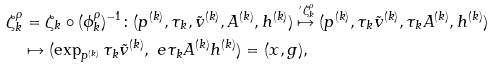<formula> <loc_0><loc_0><loc_500><loc_500>\zeta ^ { \rho } _ { k } & = \zeta _ { k } \circ ( \phi ^ { \rho } _ { k } ) ^ { - 1 } \colon ( p ^ { ( k ) } , \tau _ { k } , \tilde { v } ^ { ( k ) } , A ^ { ( k ) } , h ^ { ( k ) } ) \stackrel { \, ^ { \prime } \zeta ^ { \rho } _ { k } } { \mapsto } ( p ^ { ( k ) } , \tau _ { k } \tilde { v } ^ { ( k ) } , \tau _ { k } A ^ { ( k ) } , h ^ { ( k ) } ) \\ & \mapsto ( \exp _ { p ^ { ( k ) } } \tau _ { k } \tilde { v } ^ { ( k ) } , \ e { \tau _ { k } A ^ { ( k ) } } h ^ { ( k ) } ) = ( x , g ) ,</formula> 